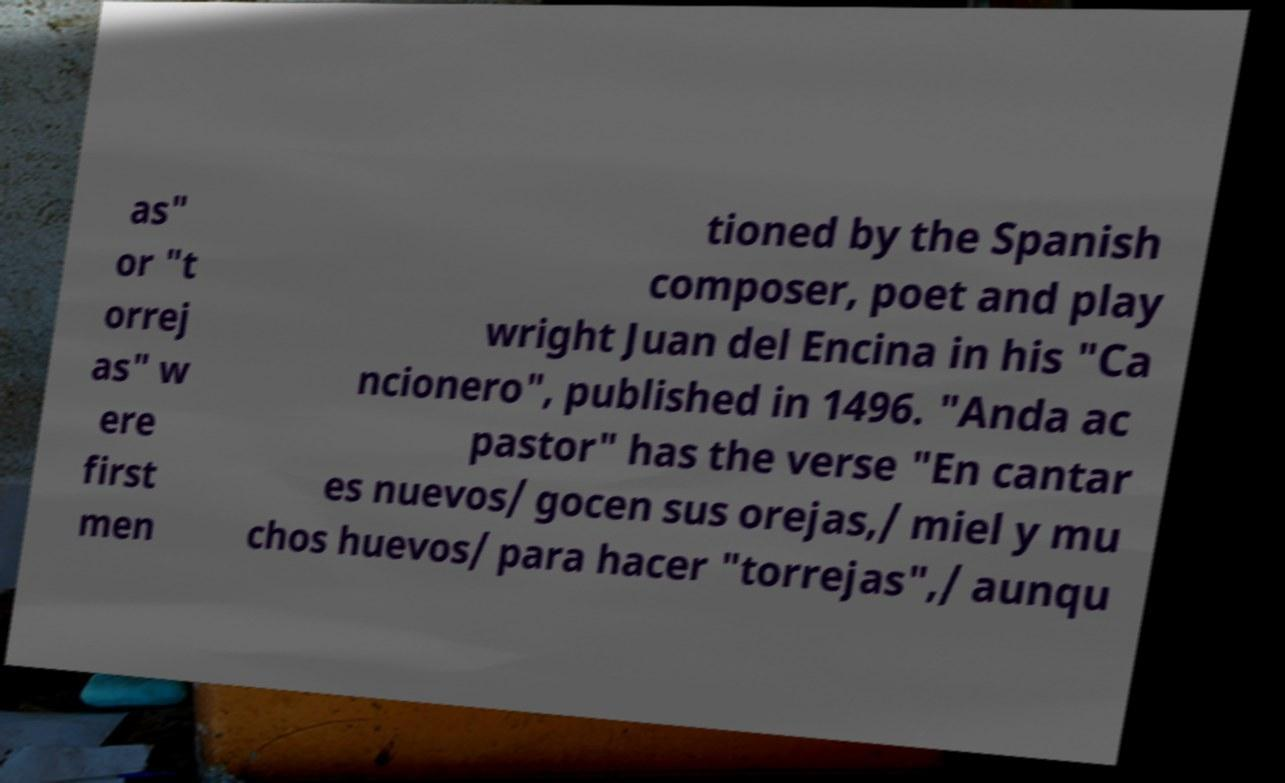Can you accurately transcribe the text from the provided image for me? as" or "t orrej as" w ere first men tioned by the Spanish composer, poet and play wright Juan del Encina in his "Ca ncionero", published in 1496. "Anda ac pastor" has the verse "En cantar es nuevos/ gocen sus orejas,/ miel y mu chos huevos/ para hacer "torrejas",/ aunqu 